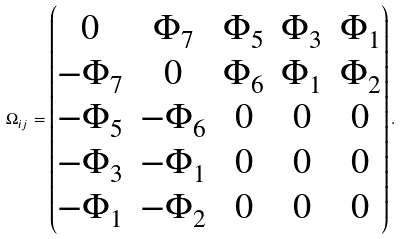Convert formula to latex. <formula><loc_0><loc_0><loc_500><loc_500>\Omega _ { i j } = \begin{pmatrix} 0 & \Phi _ { 7 } & \Phi _ { 5 } & \Phi _ { 3 } & \Phi _ { 1 } \\ - \Phi _ { 7 } & 0 & \Phi _ { 6 } & \Phi _ { 1 } & \Phi _ { 2 } \\ - \Phi _ { 5 } & - \Phi _ { 6 } & 0 & 0 & 0 \\ - \Phi _ { 3 } & - \Phi _ { 1 } & 0 & 0 & 0 \\ - \Phi _ { 1 } & - \Phi _ { 2 } & 0 & 0 & 0 \end{pmatrix} .</formula> 